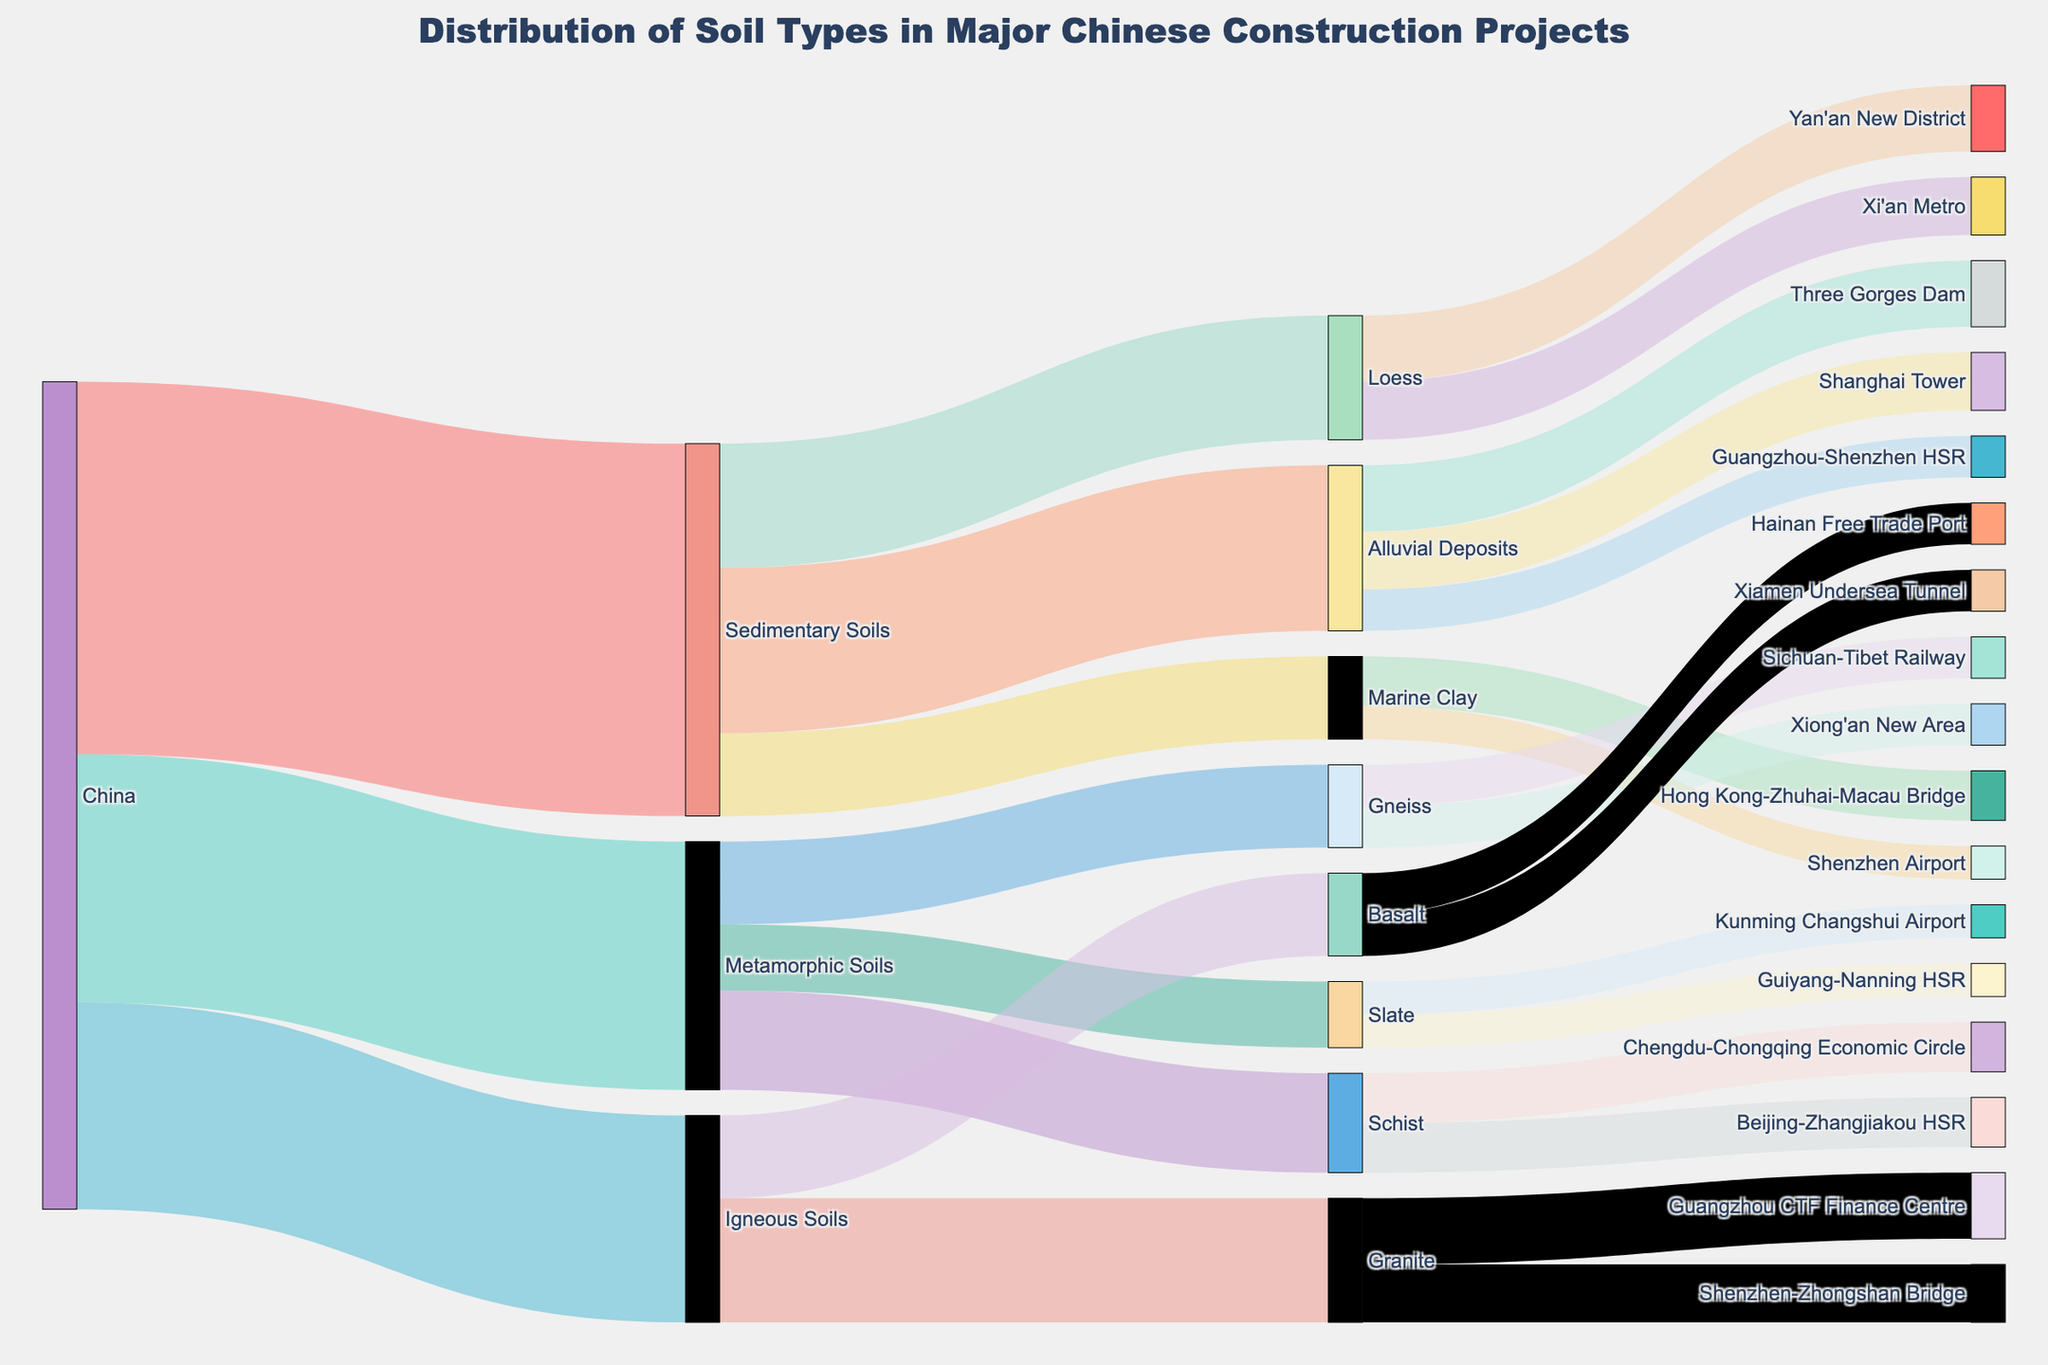what's the title of the Sankey diagram? The title is displayed at the top center of the figure. It reads "Distribution of Soil Types in Major Chinese Construction Projects"
Answer: Distribution of Soil Types in Major Chinese Construction Projects How many major soil types are sourced from China in the diagram? The figure shows connections from China to three different types of soils: Sedimentary Soils, Metamorphic Soils, and Igneous Soils.
Answer: 3 Which sedimentary soil type has the highest value and which construction projects use it? Amongst Sedimentary Soils, Alluvial Deposits have the highest value at 20. The construction projects using Alluvial Deposits are Three Gorges Dam (8), Shanghai Tower (7), and Guangzhou-Shenzhen HSR (5).
Answer: Alluvial Deposits; Three Gorges Dam, Shanghai Tower, Guangzhou-Shenzhen HSR Which specific construction project uses Marine Clay? The figure shows two projects using Marine Clay. The connections indicate Hong Kong-Zhuhai-Macau Bridge (6) and Shenzhen Airport (4).
Answer: Hong Kong-Zhuhai-Macau Bridge, Shenzhen Airport What is the total value of Metamorphic Soils used in construction projects? Each Metamorphic Soil contributes to different construction projects. Adding up the values for projects using Schist (6+6), Gneiss (5+5), and Slate (4+4) gives us the total: (6+6) + (5+5) + (4+4) = 30
Answer: 30 What is the construction project associated with the highest value of Granite and what is that value? The connections indicate that Granite is used in two projects: Guangzhou CTF Finance Centre (8) and Shenzhen-Zhongshan Bridge (7). The project with the highest value is Guangzhou CTF Finance Centre with a value of 8.
Answer: Guangzhou CTF Finance Centre, 8 Are more construction projects linked to Igneous Soils or Metamorphic Soils? Igneous Soils has connections to 2 projects for Granite and 2 for Basalt, totaling 4 projects. Metamorphic Soils have connections to 2 projects for Schist, 2 for Gneiss, and 2 for Slate, totaling 6 projects. Therefore, Metamorphic Soils are linked to more construction projects.
Answer: Metamorphic Soils Which soil type has the least amount used for construction projects in total and what are the soil sub-types? The Sankey diagram shows Igneous Soils with a total value of 25, coming from Granite (15) and Basalt (10).
Answer: Igneous Soils How many projects are connected to Loess soil type and what are their values? The diagram indicates two projects connected to Loess: Yan'an New District with a value of 8 and Xi'an Metro with a value of 7.
Answer: 2 projects; 8, 7 What is the combined value of construction projects using Basalt? The values for Basalt projects are Hainan Free Trade Port (5) and Xiamen Undersea Tunnel (5). Adding them gives the combined value: 5 + 5 = 10
Answer: 10 